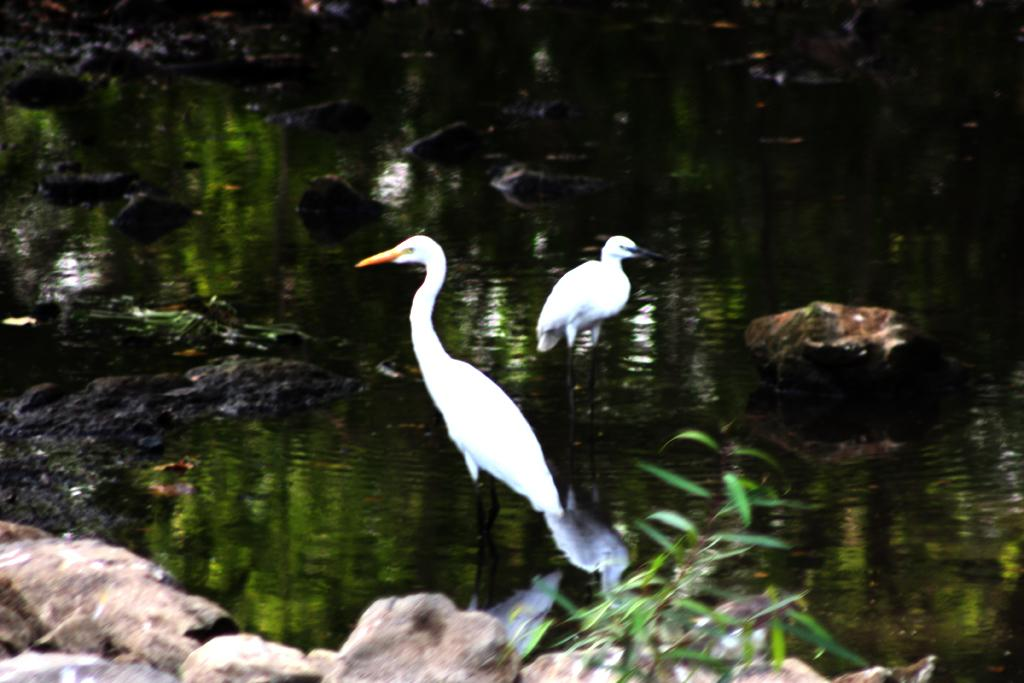How many birds can be seen in the image? There are two birds in the image. What else is present in the image besides the birds? There is a plant, stones, and water visible in the image. Can you describe the plant in the image? The provided facts do not give a detailed description of the plant, but it is present in the image. What is the condition of the background in the image? The background of the image is blurry. What type of sponge is the uncle using to clean the daughter's face in the image? There is no sponge, uncle, or daughter present in the image. 